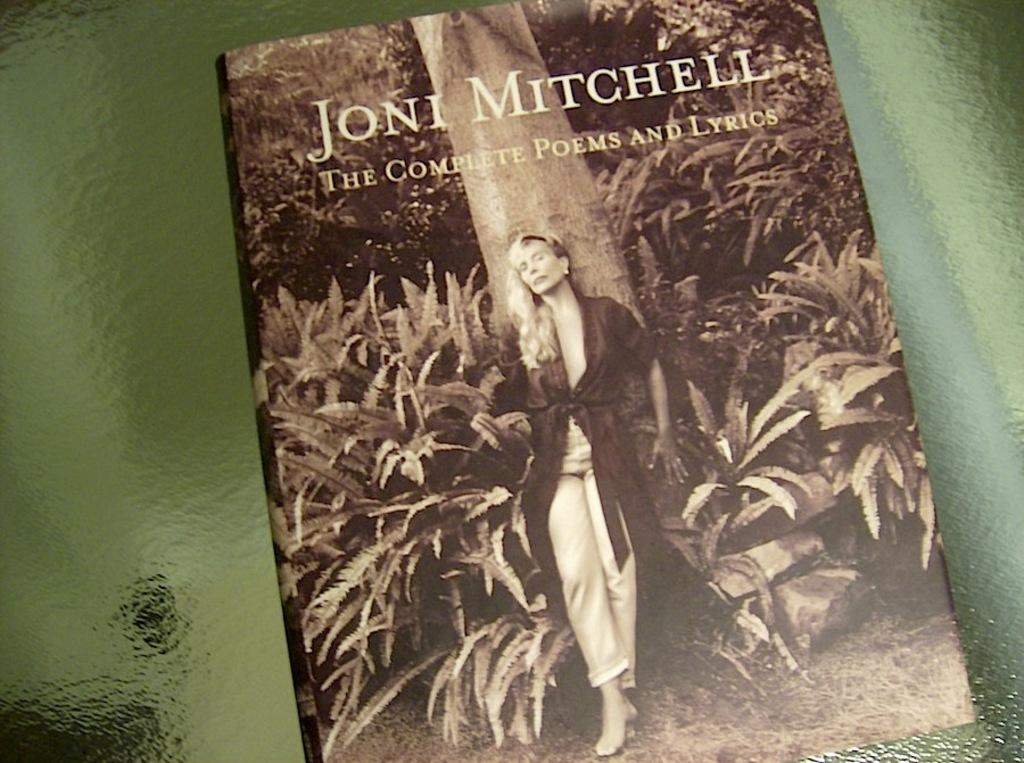<image>
Provide a brief description of the given image. Joni Mitchell wrote a book called The Complete Poems and Lyrics 